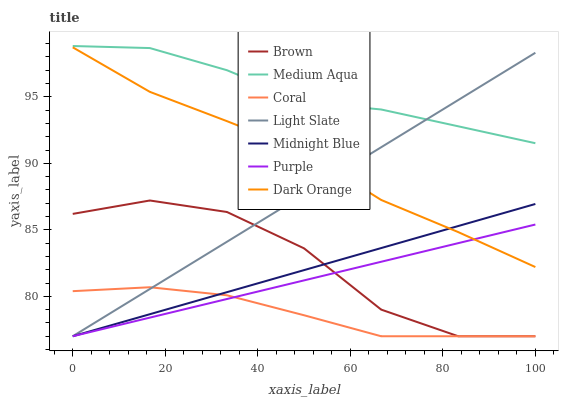Does Coral have the minimum area under the curve?
Answer yes or no. Yes. Does Medium Aqua have the maximum area under the curve?
Answer yes or no. Yes. Does Midnight Blue have the minimum area under the curve?
Answer yes or no. No. Does Midnight Blue have the maximum area under the curve?
Answer yes or no. No. Is Light Slate the smoothest?
Answer yes or no. Yes. Is Brown the roughest?
Answer yes or no. Yes. Is Midnight Blue the smoothest?
Answer yes or no. No. Is Midnight Blue the roughest?
Answer yes or no. No. Does Dark Orange have the lowest value?
Answer yes or no. No. Does Medium Aqua have the highest value?
Answer yes or no. Yes. Does Midnight Blue have the highest value?
Answer yes or no. No. Is Coral less than Medium Aqua?
Answer yes or no. Yes. Is Medium Aqua greater than Purple?
Answer yes or no. Yes. Does Purple intersect Brown?
Answer yes or no. Yes. Is Purple less than Brown?
Answer yes or no. No. Is Purple greater than Brown?
Answer yes or no. No. Does Coral intersect Medium Aqua?
Answer yes or no. No. 